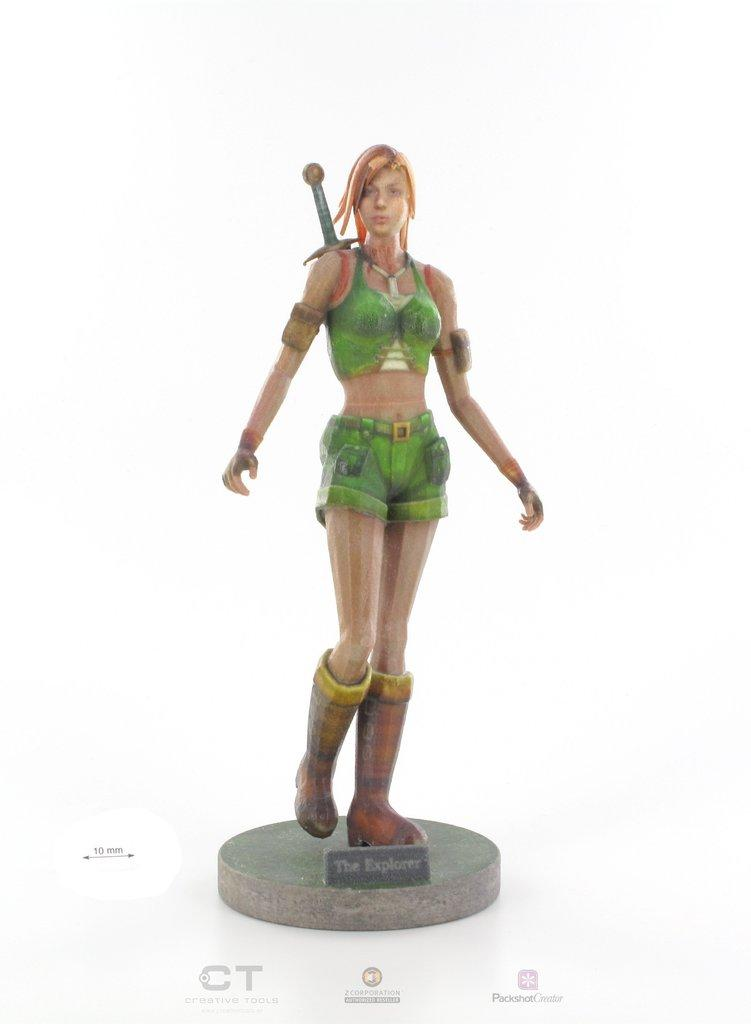What is the main subject of the image? There is a doll in the image. Can you describe the doll's appearance? The doll is in the shape of a woman. What type of fear can be seen on the doll's face in the image? There is no indication of fear on the doll's face in the image, as it is a doll and does not have emotions. 